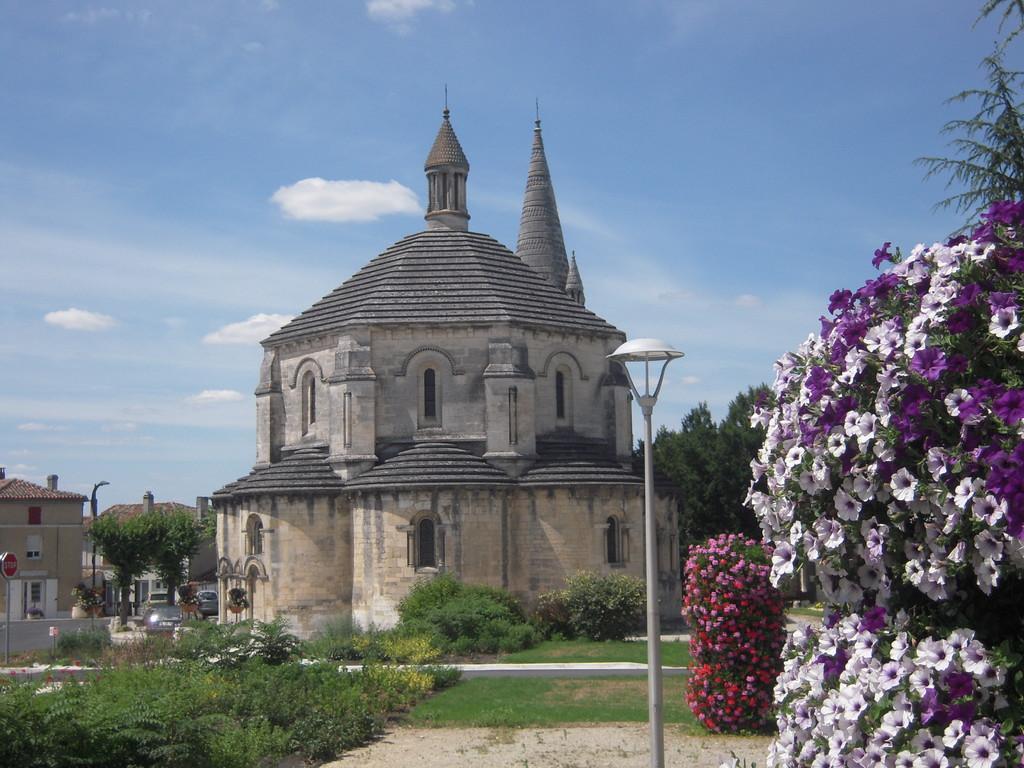In one or two sentences, can you explain what this image depicts? In this image we can see buildings, vehicles, poles, grass, plants, flowers, and a board. In the background there is sky with clouds. 